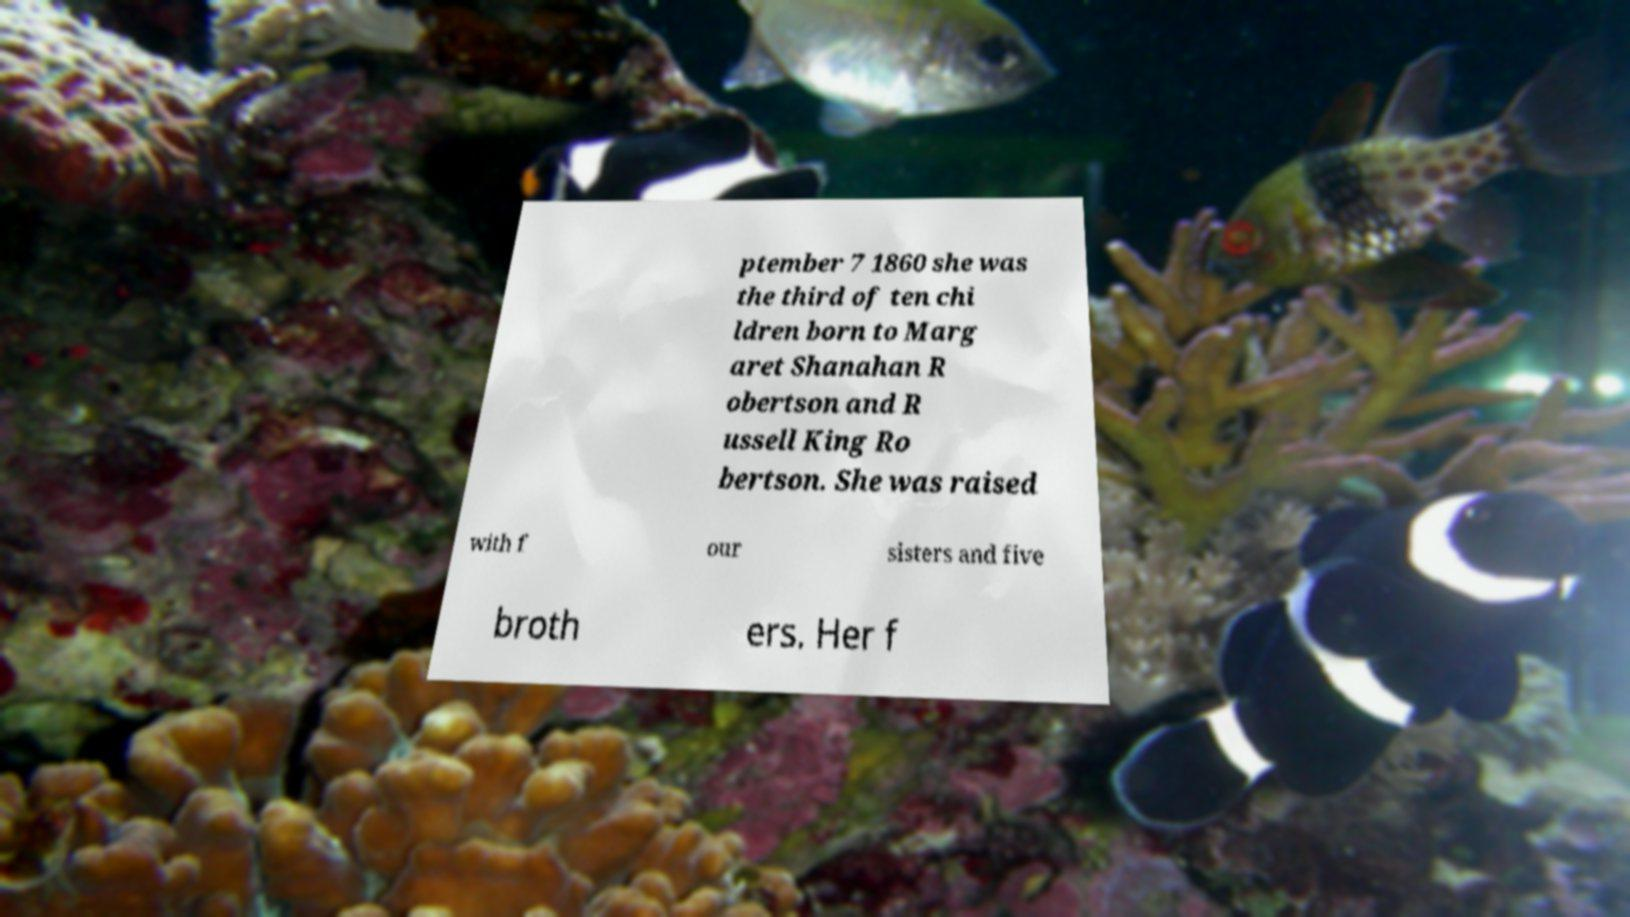Can you read and provide the text displayed in the image?This photo seems to have some interesting text. Can you extract and type it out for me? ptember 7 1860 she was the third of ten chi ldren born to Marg aret Shanahan R obertson and R ussell King Ro bertson. She was raised with f our sisters and five broth ers. Her f 